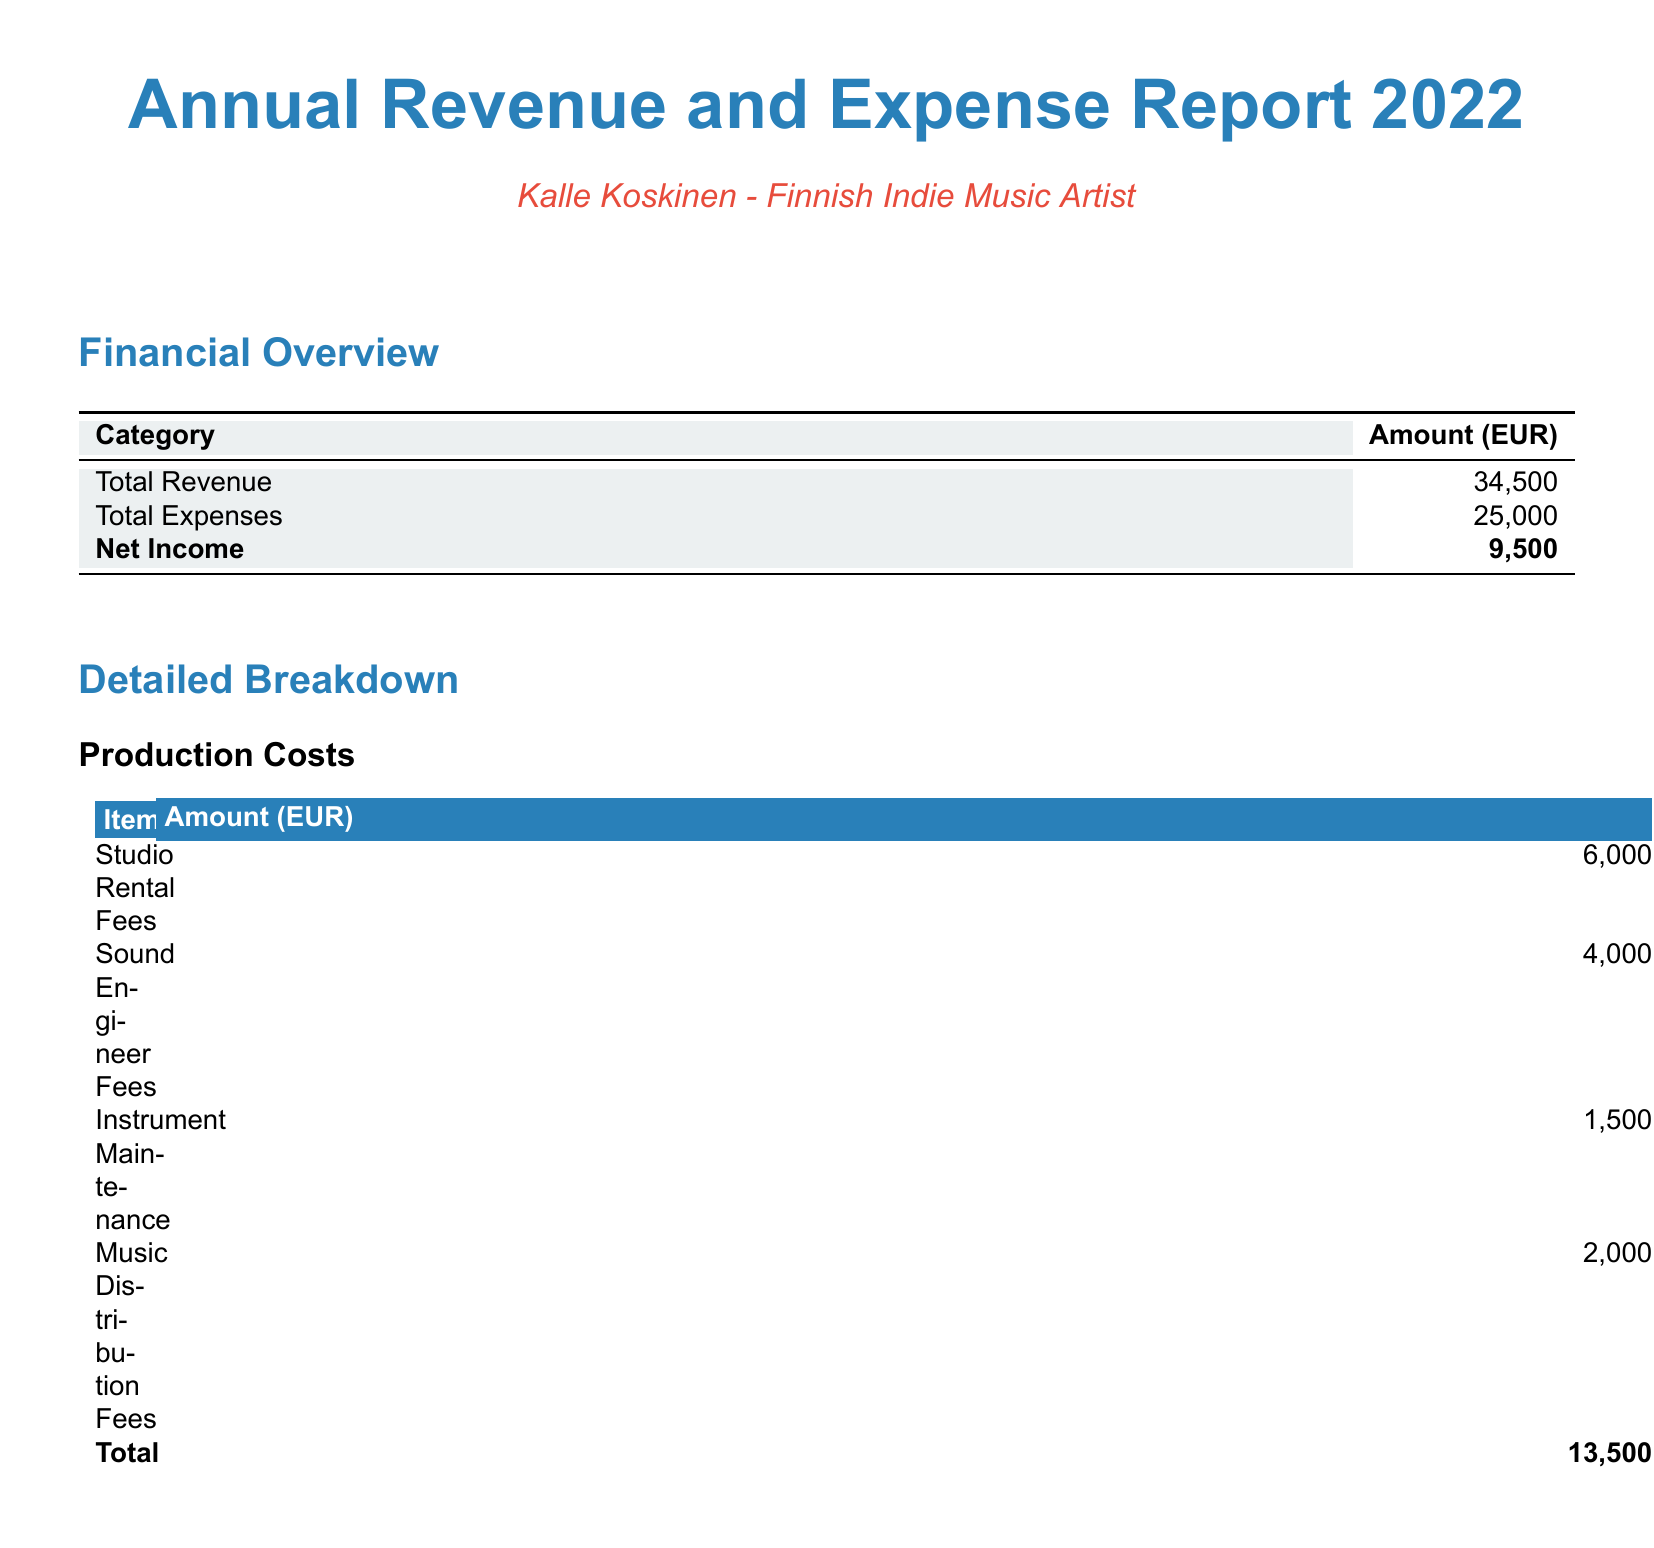what is the total revenue? The total revenue is the sum of all performance income sources in the document, which amounts to 20,000 + 8,000 + 5,000 + 1,500.
Answer: 34,500 what is the net income? The net income is calculated by subtracting total expenses from total revenue, which equals 34,500 - 25,000.
Answer: 9,500 how much was spent on studio rental fees? The amount spent on studio rental fees is clearly listed in the production costs section of the document.
Answer: 6,000 what were the marketing expenses in total? The total marketing expenses are the sum of all marketing-related costs detailed in the document.
Answer: 11,500 which category had the highest expense? By comparing the total expenses in production costs and marketing expenses, the one with the highest amount is identified.
Answer: Production Costs what is the amount for music video production? The amount for music video production is specified under the marketing expenses section.
Answer: 5,000 how much did Kalle Koskinen earn from concert ticket sales? The income generated from concert ticket sales can be found in the performance income section of the report.
Answer: 20,000 what item had the lowest costs in production? The item with the lowest cost in the production costs section is specified, based on the listed costs.
Answer: Instrument Maintenance how much was earned from private events? The earnings from private events are indicated in the performance income section of the document.
Answer: 5,000 what are the total expenses listed in the report? The total expenses are directly provided in the financial overview section of the document.
Answer: 25,000 